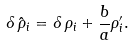<formula> <loc_0><loc_0><loc_500><loc_500>\delta \, \hat { \rho } _ { i } = \delta \, \rho _ { i } + \frac { b } { a } \rho _ { i } ^ { \prime } .</formula> 